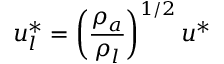<formula> <loc_0><loc_0><loc_500><loc_500>u _ { l } ^ { * } = \left ( \frac { \rho _ { a } } { \rho _ { l } } \right ) ^ { 1 / 2 } u ^ { * }</formula> 